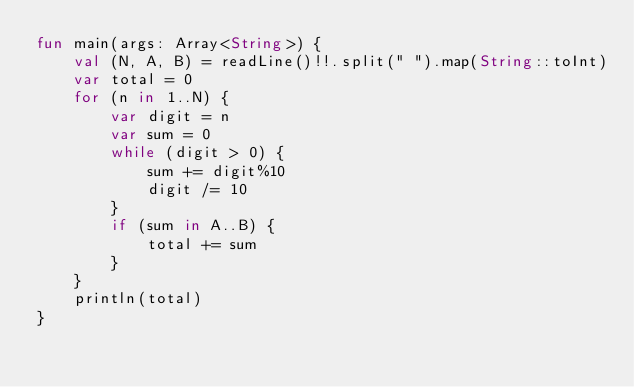<code> <loc_0><loc_0><loc_500><loc_500><_Kotlin_>fun main(args: Array<String>) {
    val (N, A, B) = readLine()!!.split(" ").map(String::toInt)
    var total = 0
    for (n in 1..N) {
        var digit = n
        var sum = 0
        while (digit > 0) {
            sum += digit%10
            digit /= 10
        }
        if (sum in A..B) {
            total += sum
        }
    }
    println(total)
}</code> 